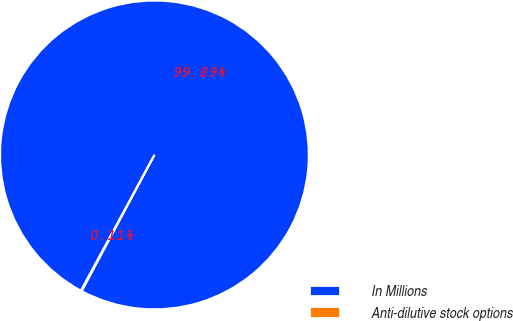<chart> <loc_0><loc_0><loc_500><loc_500><pie_chart><fcel>In Millions<fcel>Anti-dilutive stock options<nl><fcel>99.89%<fcel>0.11%<nl></chart> 